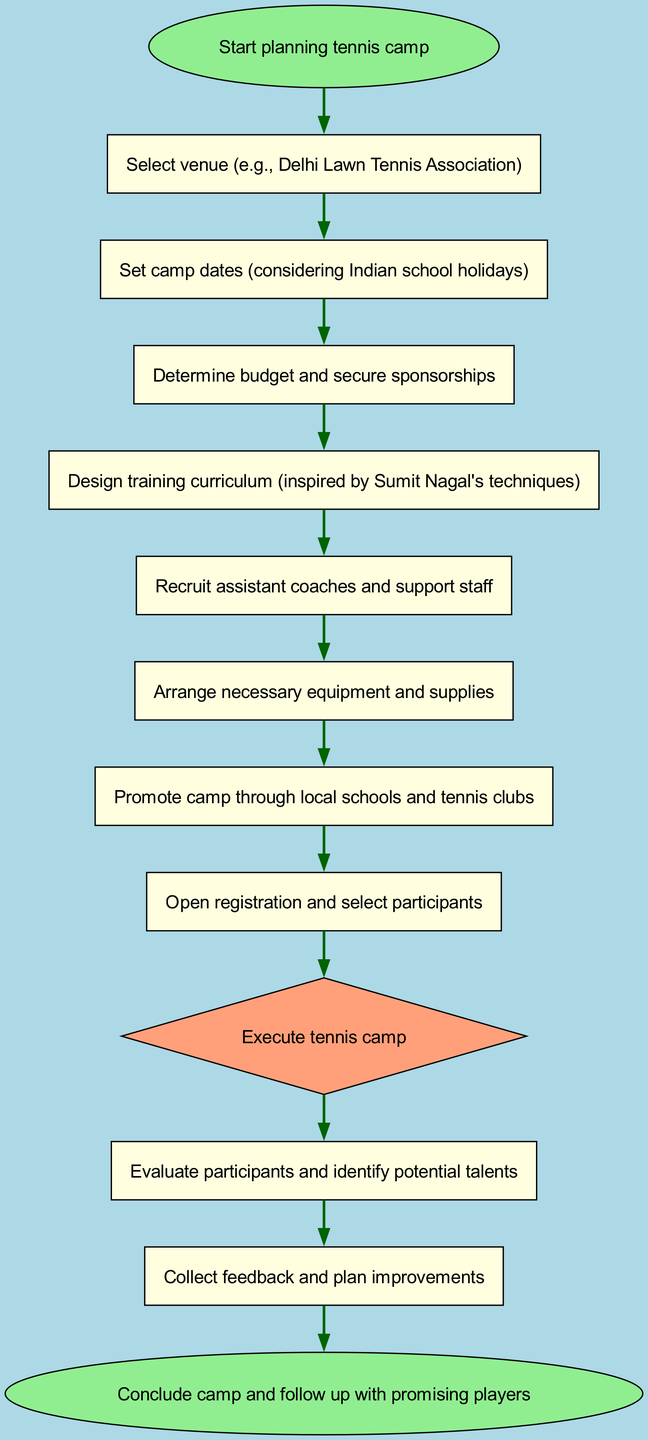What is the first step in planning the tennis camp? The first step is to start planning the tennis camp, as indicated by the 'start' node.
Answer: Start planning tennis camp How many nodes are there in the diagram? By counting all the unique steps represented as nodes in the diagram, there are a total of 13 nodes listed.
Answer: 13 What is the last step before concluding the camp? The last step before concluding the camp is to collect feedback and plan improvements, which is represented by the 'feedback' node.
Answer: Collect feedback and plan improvements Which node directly follows the 'promotion' node? The 'registration' node directly follows the 'promotion' node in the sequence of steps outlined in the diagram.
Answer: Open registration and select participants What is the purpose of the 'execution' node? The 'execution' node signifies the actual execution of the tennis camp, which is a crucial phase that follows the planning stages.
Answer: Execute tennis camp What is the relationship between 'curriculum' and 'coaches'? The 'curriculum' node leads to the 'coaches' node, indicating that the design of the training curriculum informs the recruitment of assistant coaches and support staff.
Answer: 'curriculum' leads to 'coaches' Which step involves promoting the camp? The step that involves promoting the camp is labeled as 'promotion', which follows the arrangement of necessary equipment and supplies.
Answer: Promote camp through local schools and tennis clubs How do you evaluate the success of the camp? The success of the camp is evaluated by identifying potential talents after conducting evaluations of the participants.
Answer: Evaluate participants and identify potential talents What comes after recruiting assistant coaches? After recruiting assistant coaches and support staff, the subsequent step is to arrange necessary equipment and supplies for the camp.
Answer: Arrange necessary equipment and supplies 